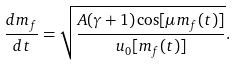Convert formula to latex. <formula><loc_0><loc_0><loc_500><loc_500>\frac { d m _ { f } } { d t } = \sqrt { \frac { A ( \gamma + 1 ) \cos [ \mu m _ { f } ( t ) ] } { u _ { 0 } [ m _ { f } ( t ) ] } } .</formula> 